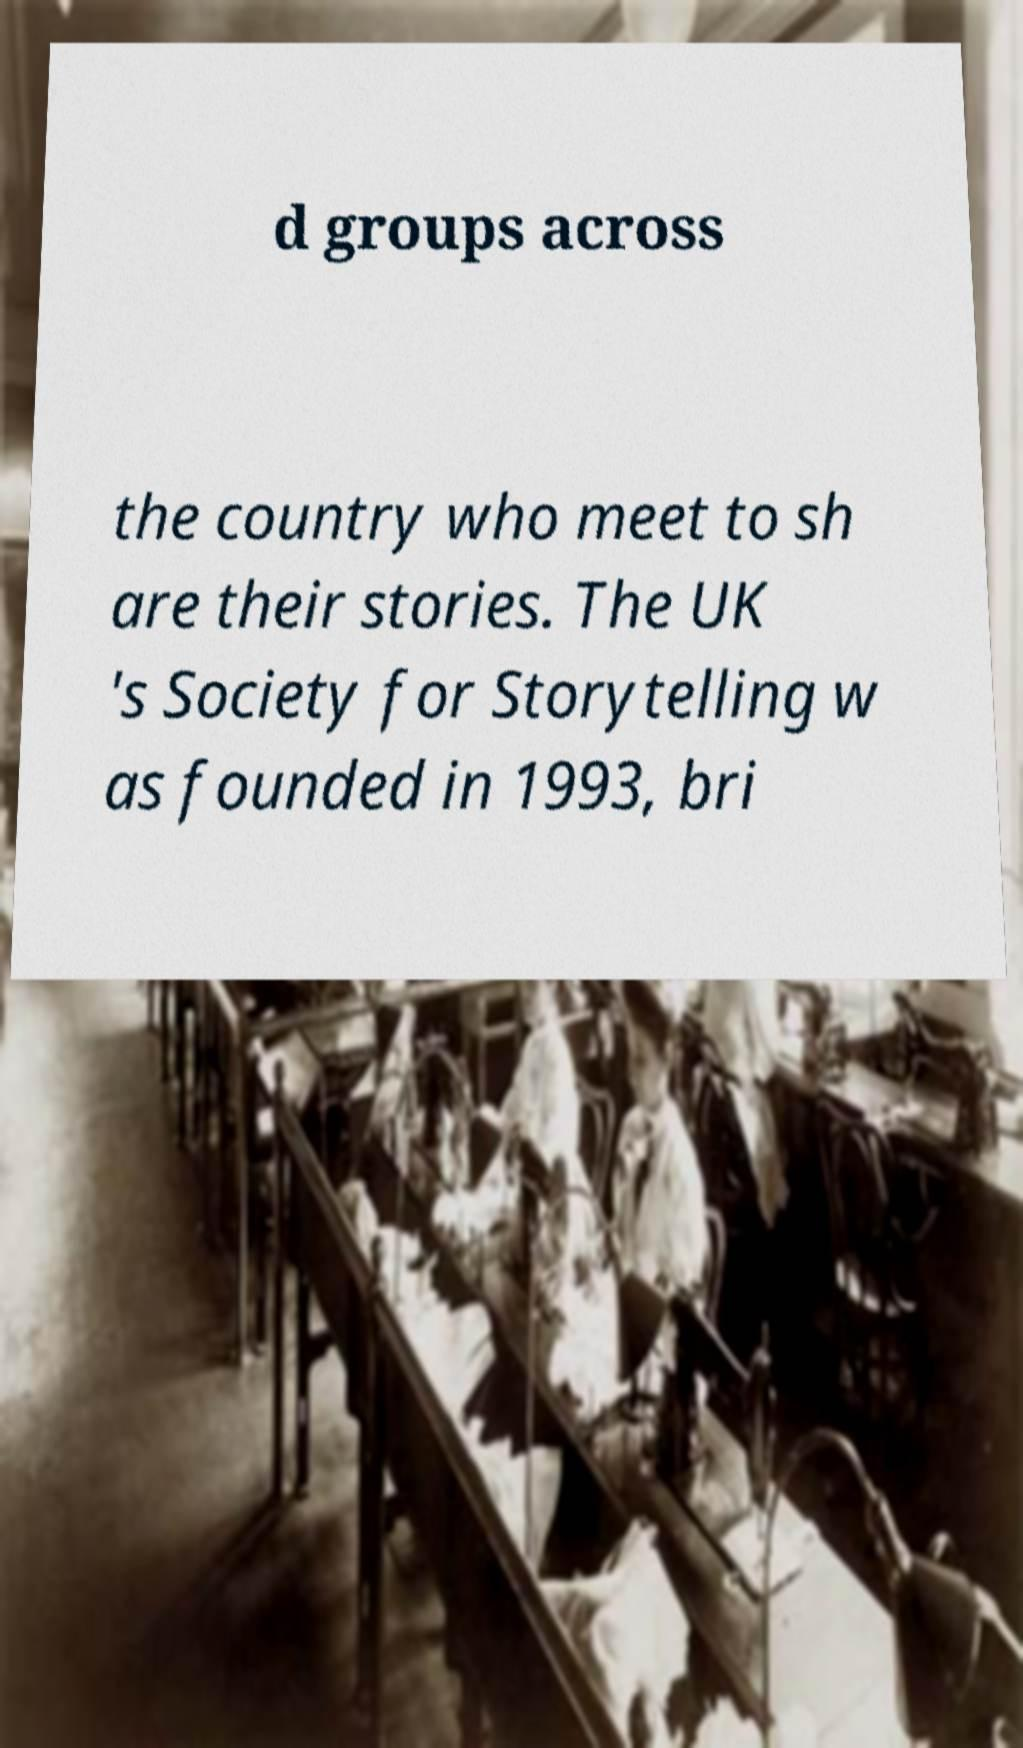Can you accurately transcribe the text from the provided image for me? d groups across the country who meet to sh are their stories. The UK 's Society for Storytelling w as founded in 1993, bri 